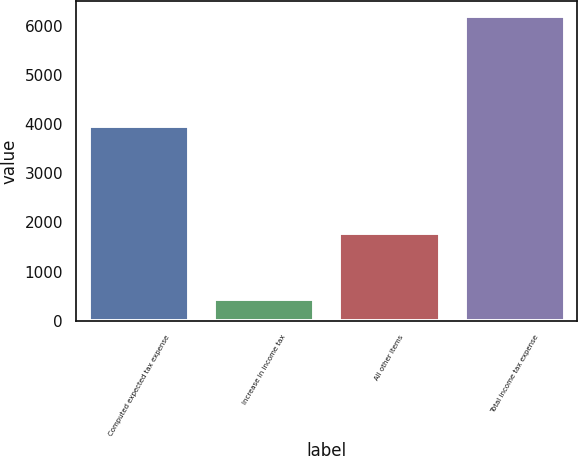Convert chart to OTSL. <chart><loc_0><loc_0><loc_500><loc_500><bar_chart><fcel>Computed expected tax expense<fcel>Increase in income tax<fcel>All other items<fcel>Total income tax expense<nl><fcel>3974<fcel>443<fcel>1782<fcel>6199<nl></chart> 